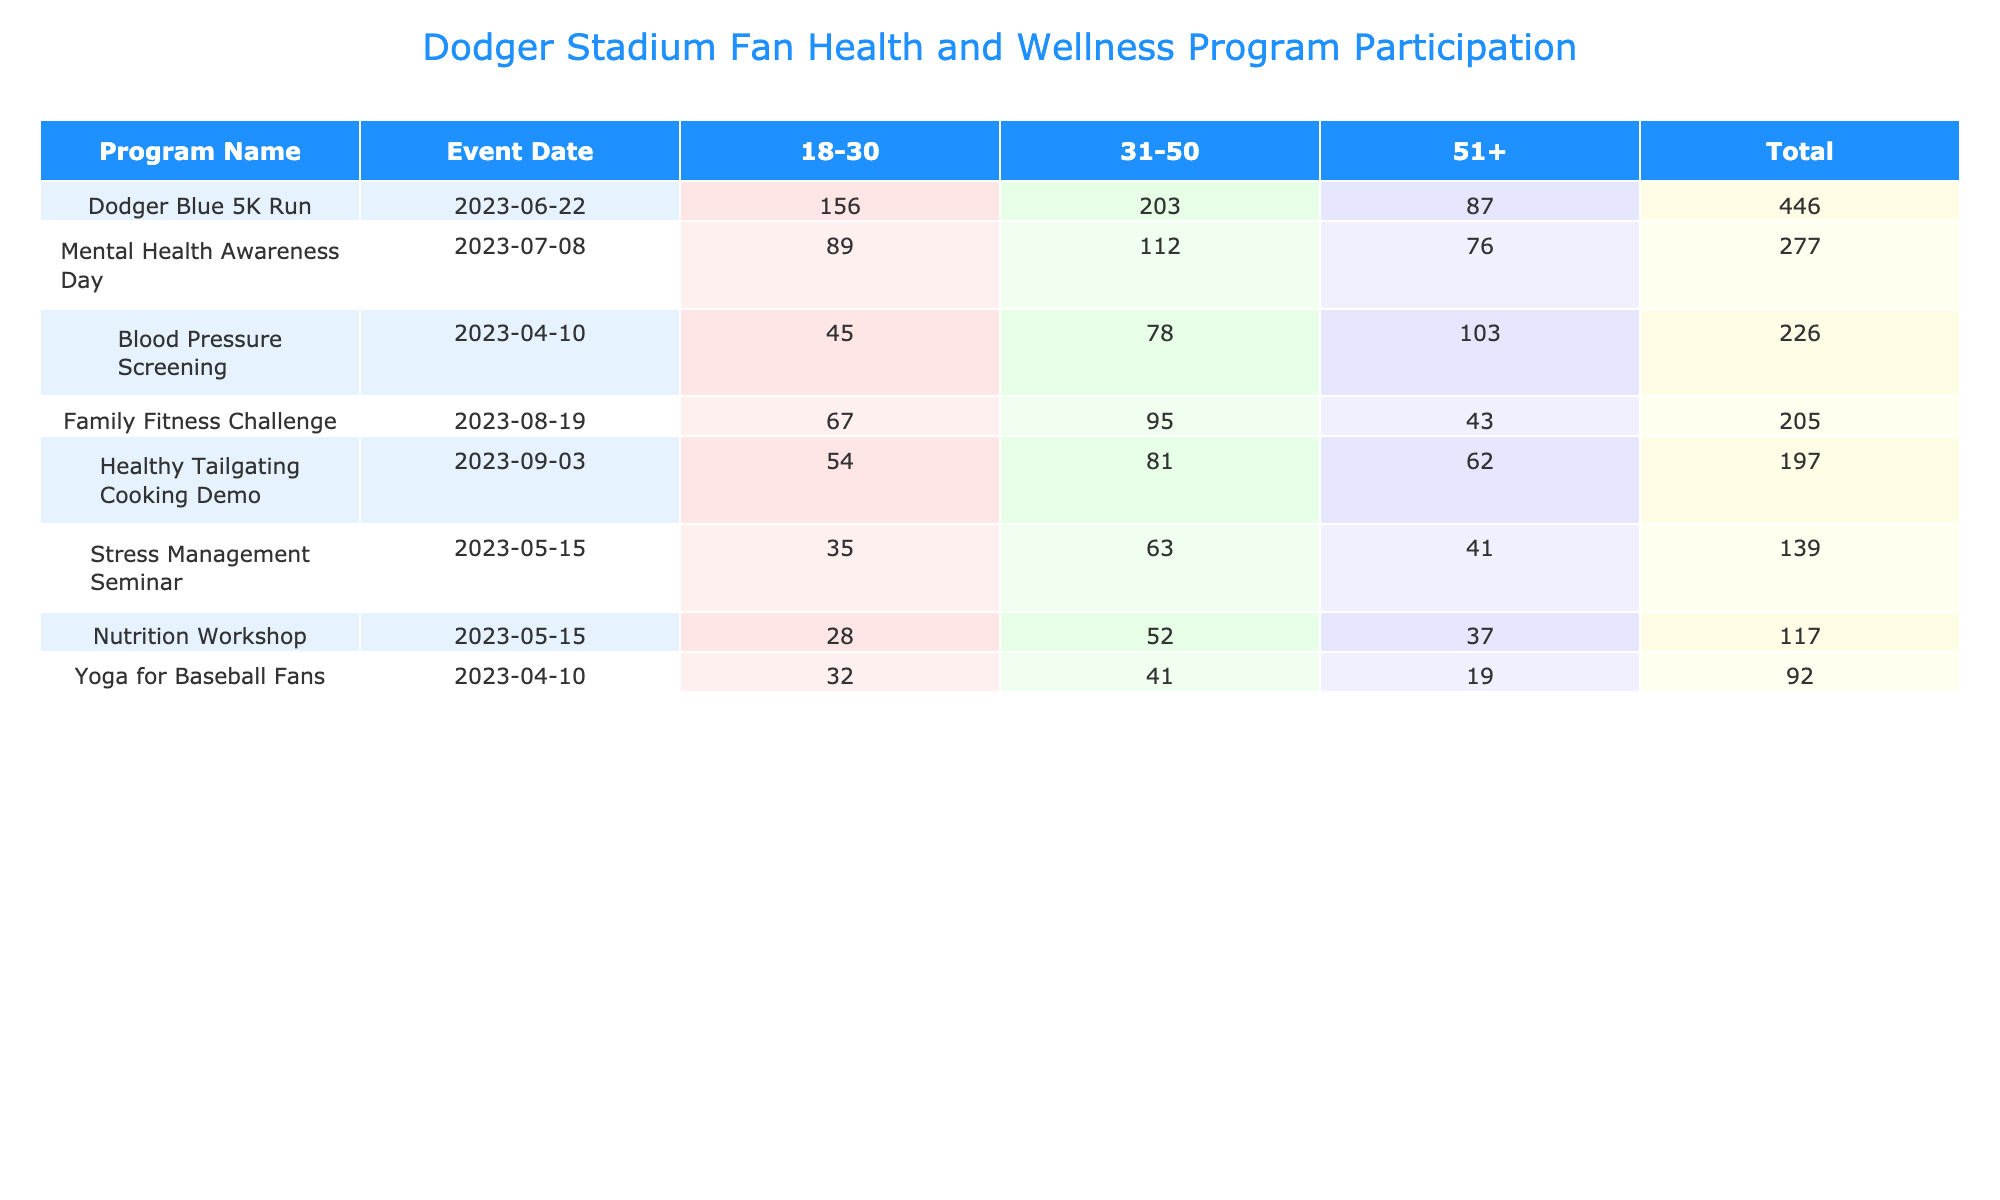What is the total participation count for the Yoga for Baseball Fans program? To find the total participation for the Yoga for Baseball Fans program, I look at the rows for this program in the table. The participation counts for different age groups are 32 (18-30), 41 (31-50), and 19 (51+). Adding these values gives 32 + 41 + 19 = 92.
Answer: 92 Which program had the highest participation on June 22, 2023? On June 22, 2023, the Dodger Blue 5K Run program had participation counts of 156 (age 18-30), 203 (age 31-50), and 87 (age 51+). By adding these counts, the total for this program is 156 + 203 + 87 = 446, which is greater than any other program on that date.
Answer: Dodger Blue 5K Run Did the Nutrition Workshop have a higher participation rate from ages 31-50 or 51+? The participation count for the Nutrition Workshop from age 31-50 is 52, while for age 51+, it is 37. Since 52 is greater than 37, the program had a higher participation rate from ages 31-50.
Answer: Yes What is the average satisfaction rating for the Mental Health Awareness Day program across all age groups? The satisfaction ratings for the Mental Health Awareness Day program are 4.6 (18-30), 4.7 (31-50), and 4.8 (51+). To find the average, I add these values (4.6 + 4.7 + 4.8 = 14.1) and divide by 3 (there are three age groups). The average is 14.1 / 3 = 4.7.
Answer: 4.7 Which event had the lowest total participation, and what was that count? I will calculate the total participation for each program by summing the participation counts across all age groups. The Healthy Tailgating Cooking Demo has participation counts of 54 (age 18-30), 81 (age 31-50), and 62 (age 51+), totaling 54 + 81 + 62 = 197. Upon comparing with other programs, this is the lowest total participation.
Answer: 197 